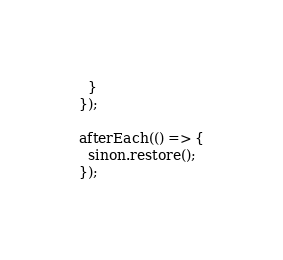Convert code to text. <code><loc_0><loc_0><loc_500><loc_500><_TypeScript_>  }
});

afterEach(() => {
  sinon.restore();
});
</code> 